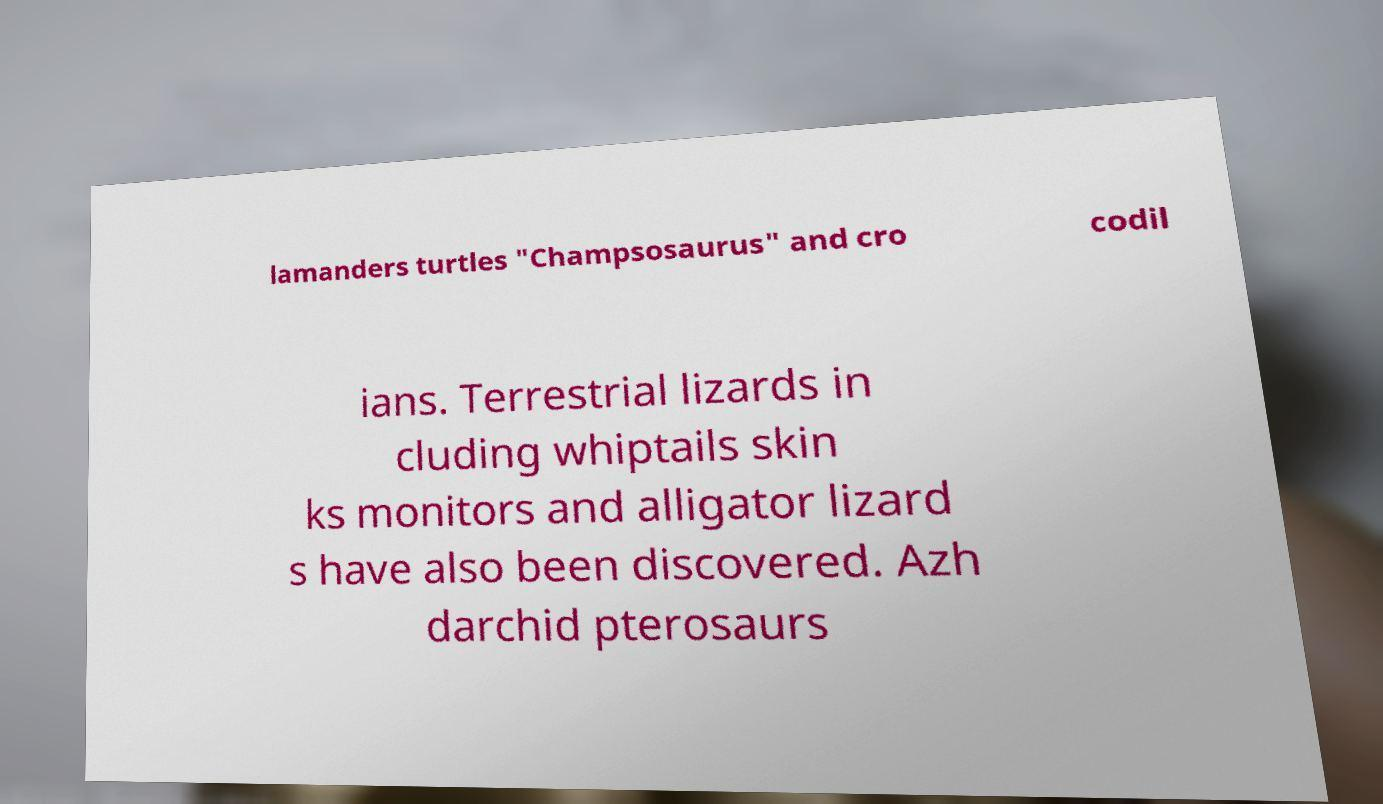Could you assist in decoding the text presented in this image and type it out clearly? lamanders turtles "Champsosaurus" and cro codil ians. Terrestrial lizards in cluding whiptails skin ks monitors and alligator lizard s have also been discovered. Azh darchid pterosaurs 